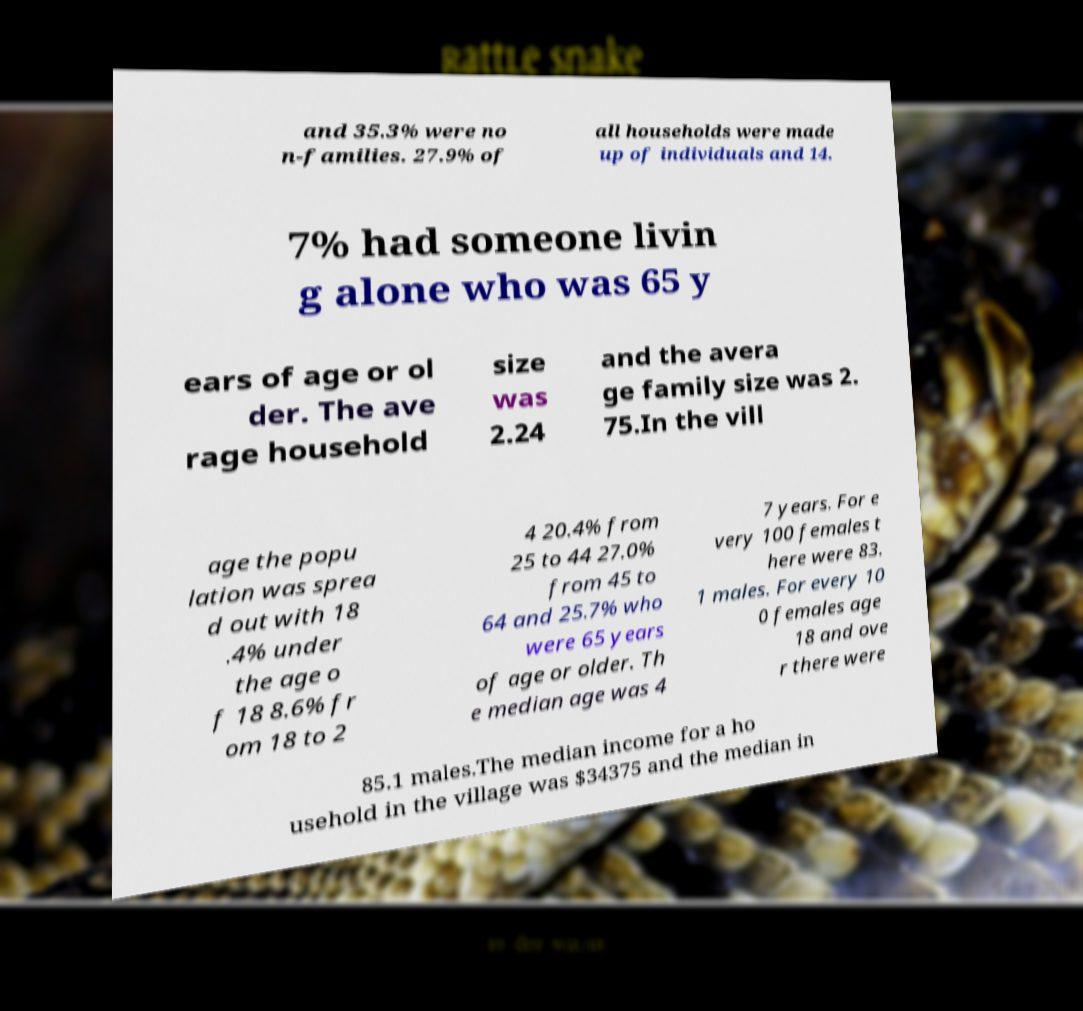For documentation purposes, I need the text within this image transcribed. Could you provide that? and 35.3% were no n-families. 27.9% of all households were made up of individuals and 14. 7% had someone livin g alone who was 65 y ears of age or ol der. The ave rage household size was 2.24 and the avera ge family size was 2. 75.In the vill age the popu lation was sprea d out with 18 .4% under the age o f 18 8.6% fr om 18 to 2 4 20.4% from 25 to 44 27.0% from 45 to 64 and 25.7% who were 65 years of age or older. Th e median age was 4 7 years. For e very 100 females t here were 83. 1 males. For every 10 0 females age 18 and ove r there were 85.1 males.The median income for a ho usehold in the village was $34375 and the median in 